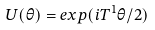<formula> <loc_0><loc_0><loc_500><loc_500>U ( \theta ) = e x p ( i T ^ { 1 } \theta / 2 )</formula> 